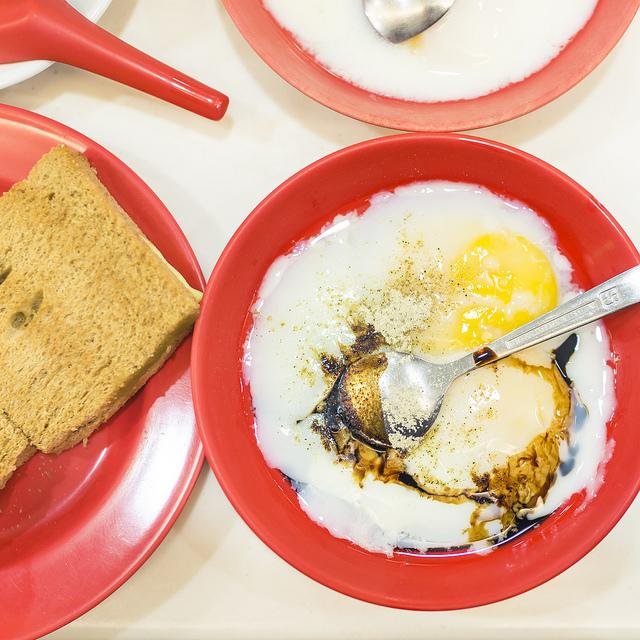Which food offers the most protein?

Choices:
A) ginger
B) pudding
C) bread
D) egg egg 